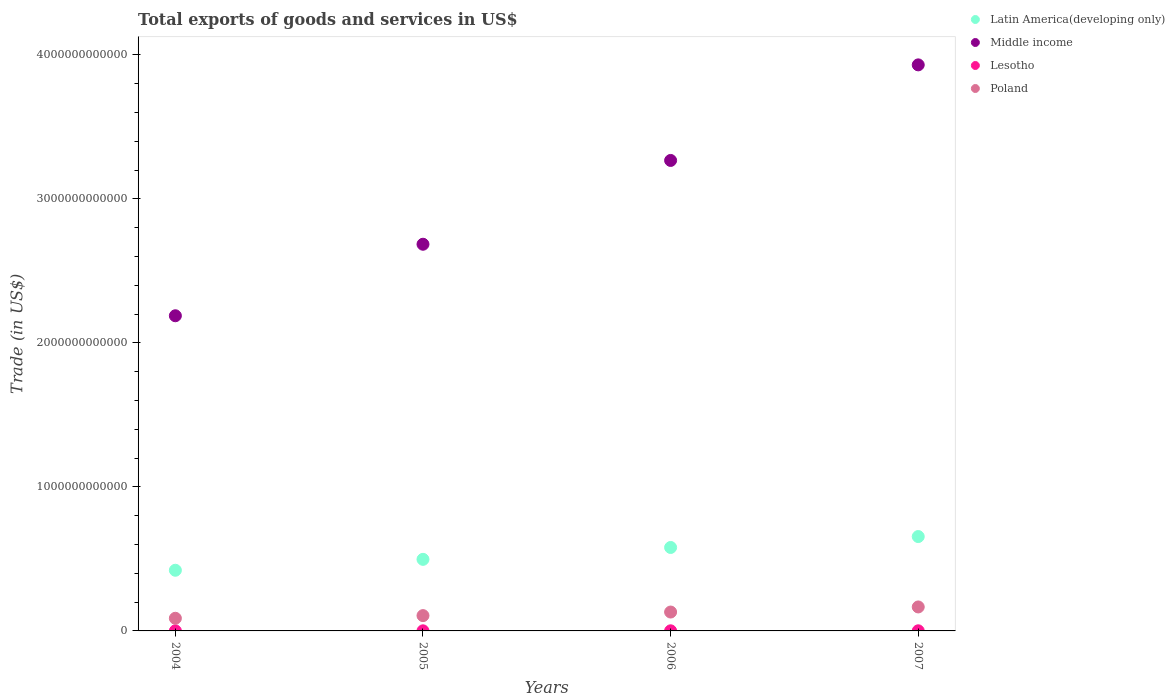How many different coloured dotlines are there?
Your answer should be very brief. 4. What is the total exports of goods and services in Poland in 2007?
Provide a succinct answer. 1.66e+11. Across all years, what is the maximum total exports of goods and services in Lesotho?
Your answer should be very brief. 8.32e+08. Across all years, what is the minimum total exports of goods and services in Lesotho?
Your answer should be compact. 6.69e+08. What is the total total exports of goods and services in Middle income in the graph?
Ensure brevity in your answer.  1.21e+13. What is the difference between the total exports of goods and services in Poland in 2005 and that in 2006?
Give a very brief answer. -2.48e+1. What is the difference between the total exports of goods and services in Middle income in 2004 and the total exports of goods and services in Lesotho in 2005?
Your response must be concise. 2.19e+12. What is the average total exports of goods and services in Lesotho per year?
Provide a succinct answer. 7.40e+08. In the year 2007, what is the difference between the total exports of goods and services in Lesotho and total exports of goods and services in Latin America(developing only)?
Give a very brief answer. -6.54e+11. What is the ratio of the total exports of goods and services in Latin America(developing only) in 2006 to that in 2007?
Keep it short and to the point. 0.88. Is the difference between the total exports of goods and services in Lesotho in 2005 and 2006 greater than the difference between the total exports of goods and services in Latin America(developing only) in 2005 and 2006?
Keep it short and to the point. Yes. What is the difference between the highest and the second highest total exports of goods and services in Poland?
Your response must be concise. 3.53e+1. What is the difference between the highest and the lowest total exports of goods and services in Poland?
Offer a terse response. 7.86e+1. In how many years, is the total exports of goods and services in Middle income greater than the average total exports of goods and services in Middle income taken over all years?
Provide a short and direct response. 2. Is the sum of the total exports of goods and services in Middle income in 2004 and 2007 greater than the maximum total exports of goods and services in Latin America(developing only) across all years?
Keep it short and to the point. Yes. Is it the case that in every year, the sum of the total exports of goods and services in Latin America(developing only) and total exports of goods and services in Middle income  is greater than the total exports of goods and services in Lesotho?
Give a very brief answer. Yes. Is the total exports of goods and services in Lesotho strictly greater than the total exports of goods and services in Poland over the years?
Offer a terse response. No. Is the total exports of goods and services in Lesotho strictly less than the total exports of goods and services in Middle income over the years?
Your response must be concise. Yes. How many years are there in the graph?
Offer a terse response. 4. What is the difference between two consecutive major ticks on the Y-axis?
Offer a terse response. 1.00e+12. Are the values on the major ticks of Y-axis written in scientific E-notation?
Provide a short and direct response. No. Does the graph contain any zero values?
Keep it short and to the point. No. What is the title of the graph?
Give a very brief answer. Total exports of goods and services in US$. What is the label or title of the Y-axis?
Your answer should be compact. Trade (in US$). What is the Trade (in US$) in Latin America(developing only) in 2004?
Give a very brief answer. 4.21e+11. What is the Trade (in US$) in Middle income in 2004?
Your answer should be very brief. 2.19e+12. What is the Trade (in US$) in Lesotho in 2004?
Your answer should be compact. 6.96e+08. What is the Trade (in US$) in Poland in 2004?
Keep it short and to the point. 8.78e+1. What is the Trade (in US$) in Latin America(developing only) in 2005?
Provide a succinct answer. 4.97e+11. What is the Trade (in US$) of Middle income in 2005?
Offer a terse response. 2.69e+12. What is the Trade (in US$) in Lesotho in 2005?
Offer a very short reply. 6.69e+08. What is the Trade (in US$) of Poland in 2005?
Offer a terse response. 1.06e+11. What is the Trade (in US$) in Latin America(developing only) in 2006?
Your response must be concise. 5.80e+11. What is the Trade (in US$) of Middle income in 2006?
Your answer should be very brief. 3.27e+12. What is the Trade (in US$) in Lesotho in 2006?
Make the answer very short. 7.65e+08. What is the Trade (in US$) of Poland in 2006?
Your answer should be compact. 1.31e+11. What is the Trade (in US$) in Latin America(developing only) in 2007?
Provide a short and direct response. 6.55e+11. What is the Trade (in US$) in Middle income in 2007?
Provide a short and direct response. 3.93e+12. What is the Trade (in US$) in Lesotho in 2007?
Your response must be concise. 8.32e+08. What is the Trade (in US$) in Poland in 2007?
Your response must be concise. 1.66e+11. Across all years, what is the maximum Trade (in US$) of Latin America(developing only)?
Your answer should be compact. 6.55e+11. Across all years, what is the maximum Trade (in US$) of Middle income?
Your answer should be very brief. 3.93e+12. Across all years, what is the maximum Trade (in US$) in Lesotho?
Provide a succinct answer. 8.32e+08. Across all years, what is the maximum Trade (in US$) in Poland?
Your response must be concise. 1.66e+11. Across all years, what is the minimum Trade (in US$) of Latin America(developing only)?
Provide a succinct answer. 4.21e+11. Across all years, what is the minimum Trade (in US$) in Middle income?
Keep it short and to the point. 2.19e+12. Across all years, what is the minimum Trade (in US$) in Lesotho?
Provide a short and direct response. 6.69e+08. Across all years, what is the minimum Trade (in US$) in Poland?
Offer a terse response. 8.78e+1. What is the total Trade (in US$) of Latin America(developing only) in the graph?
Your answer should be very brief. 2.15e+12. What is the total Trade (in US$) in Middle income in the graph?
Offer a terse response. 1.21e+13. What is the total Trade (in US$) in Lesotho in the graph?
Give a very brief answer. 2.96e+09. What is the total Trade (in US$) of Poland in the graph?
Your response must be concise. 4.92e+11. What is the difference between the Trade (in US$) of Latin America(developing only) in 2004 and that in 2005?
Offer a terse response. -7.57e+1. What is the difference between the Trade (in US$) of Middle income in 2004 and that in 2005?
Your response must be concise. -4.97e+11. What is the difference between the Trade (in US$) of Lesotho in 2004 and that in 2005?
Ensure brevity in your answer.  2.69e+07. What is the difference between the Trade (in US$) of Poland in 2004 and that in 2005?
Give a very brief answer. -1.85e+1. What is the difference between the Trade (in US$) of Latin America(developing only) in 2004 and that in 2006?
Offer a terse response. -1.58e+11. What is the difference between the Trade (in US$) of Middle income in 2004 and that in 2006?
Provide a short and direct response. -1.08e+12. What is the difference between the Trade (in US$) of Lesotho in 2004 and that in 2006?
Your response must be concise. -6.94e+07. What is the difference between the Trade (in US$) in Poland in 2004 and that in 2006?
Your response must be concise. -4.33e+1. What is the difference between the Trade (in US$) of Latin America(developing only) in 2004 and that in 2007?
Offer a very short reply. -2.34e+11. What is the difference between the Trade (in US$) of Middle income in 2004 and that in 2007?
Offer a terse response. -1.74e+12. What is the difference between the Trade (in US$) in Lesotho in 2004 and that in 2007?
Provide a short and direct response. -1.37e+08. What is the difference between the Trade (in US$) in Poland in 2004 and that in 2007?
Your response must be concise. -7.86e+1. What is the difference between the Trade (in US$) in Latin America(developing only) in 2005 and that in 2006?
Your answer should be very brief. -8.25e+1. What is the difference between the Trade (in US$) in Middle income in 2005 and that in 2006?
Your answer should be compact. -5.82e+11. What is the difference between the Trade (in US$) of Lesotho in 2005 and that in 2006?
Offer a very short reply. -9.64e+07. What is the difference between the Trade (in US$) of Poland in 2005 and that in 2006?
Provide a short and direct response. -2.48e+1. What is the difference between the Trade (in US$) of Latin America(developing only) in 2005 and that in 2007?
Provide a short and direct response. -1.58e+11. What is the difference between the Trade (in US$) in Middle income in 2005 and that in 2007?
Your response must be concise. -1.25e+12. What is the difference between the Trade (in US$) of Lesotho in 2005 and that in 2007?
Ensure brevity in your answer.  -1.63e+08. What is the difference between the Trade (in US$) of Poland in 2005 and that in 2007?
Provide a succinct answer. -6.02e+1. What is the difference between the Trade (in US$) in Latin America(developing only) in 2006 and that in 2007?
Keep it short and to the point. -7.58e+1. What is the difference between the Trade (in US$) in Middle income in 2006 and that in 2007?
Your answer should be compact. -6.64e+11. What is the difference between the Trade (in US$) in Lesotho in 2006 and that in 2007?
Make the answer very short. -6.71e+07. What is the difference between the Trade (in US$) of Poland in 2006 and that in 2007?
Give a very brief answer. -3.53e+1. What is the difference between the Trade (in US$) of Latin America(developing only) in 2004 and the Trade (in US$) of Middle income in 2005?
Your answer should be compact. -2.26e+12. What is the difference between the Trade (in US$) of Latin America(developing only) in 2004 and the Trade (in US$) of Lesotho in 2005?
Ensure brevity in your answer.  4.21e+11. What is the difference between the Trade (in US$) in Latin America(developing only) in 2004 and the Trade (in US$) in Poland in 2005?
Your answer should be compact. 3.15e+11. What is the difference between the Trade (in US$) in Middle income in 2004 and the Trade (in US$) in Lesotho in 2005?
Ensure brevity in your answer.  2.19e+12. What is the difference between the Trade (in US$) in Middle income in 2004 and the Trade (in US$) in Poland in 2005?
Your answer should be compact. 2.08e+12. What is the difference between the Trade (in US$) in Lesotho in 2004 and the Trade (in US$) in Poland in 2005?
Your answer should be very brief. -1.06e+11. What is the difference between the Trade (in US$) in Latin America(developing only) in 2004 and the Trade (in US$) in Middle income in 2006?
Your response must be concise. -2.85e+12. What is the difference between the Trade (in US$) of Latin America(developing only) in 2004 and the Trade (in US$) of Lesotho in 2006?
Your answer should be very brief. 4.21e+11. What is the difference between the Trade (in US$) in Latin America(developing only) in 2004 and the Trade (in US$) in Poland in 2006?
Your answer should be compact. 2.90e+11. What is the difference between the Trade (in US$) of Middle income in 2004 and the Trade (in US$) of Lesotho in 2006?
Provide a succinct answer. 2.19e+12. What is the difference between the Trade (in US$) in Middle income in 2004 and the Trade (in US$) in Poland in 2006?
Your answer should be compact. 2.06e+12. What is the difference between the Trade (in US$) in Lesotho in 2004 and the Trade (in US$) in Poland in 2006?
Provide a succinct answer. -1.30e+11. What is the difference between the Trade (in US$) of Latin America(developing only) in 2004 and the Trade (in US$) of Middle income in 2007?
Keep it short and to the point. -3.51e+12. What is the difference between the Trade (in US$) in Latin America(developing only) in 2004 and the Trade (in US$) in Lesotho in 2007?
Your response must be concise. 4.20e+11. What is the difference between the Trade (in US$) of Latin America(developing only) in 2004 and the Trade (in US$) of Poland in 2007?
Your answer should be very brief. 2.55e+11. What is the difference between the Trade (in US$) of Middle income in 2004 and the Trade (in US$) of Lesotho in 2007?
Give a very brief answer. 2.19e+12. What is the difference between the Trade (in US$) of Middle income in 2004 and the Trade (in US$) of Poland in 2007?
Offer a very short reply. 2.02e+12. What is the difference between the Trade (in US$) in Lesotho in 2004 and the Trade (in US$) in Poland in 2007?
Offer a very short reply. -1.66e+11. What is the difference between the Trade (in US$) of Latin America(developing only) in 2005 and the Trade (in US$) of Middle income in 2006?
Provide a short and direct response. -2.77e+12. What is the difference between the Trade (in US$) in Latin America(developing only) in 2005 and the Trade (in US$) in Lesotho in 2006?
Your answer should be very brief. 4.96e+11. What is the difference between the Trade (in US$) in Latin America(developing only) in 2005 and the Trade (in US$) in Poland in 2006?
Keep it short and to the point. 3.66e+11. What is the difference between the Trade (in US$) in Middle income in 2005 and the Trade (in US$) in Lesotho in 2006?
Give a very brief answer. 2.68e+12. What is the difference between the Trade (in US$) in Middle income in 2005 and the Trade (in US$) in Poland in 2006?
Keep it short and to the point. 2.55e+12. What is the difference between the Trade (in US$) of Lesotho in 2005 and the Trade (in US$) of Poland in 2006?
Provide a succinct answer. -1.30e+11. What is the difference between the Trade (in US$) in Latin America(developing only) in 2005 and the Trade (in US$) in Middle income in 2007?
Your answer should be very brief. -3.43e+12. What is the difference between the Trade (in US$) of Latin America(developing only) in 2005 and the Trade (in US$) of Lesotho in 2007?
Your response must be concise. 4.96e+11. What is the difference between the Trade (in US$) of Latin America(developing only) in 2005 and the Trade (in US$) of Poland in 2007?
Provide a short and direct response. 3.31e+11. What is the difference between the Trade (in US$) of Middle income in 2005 and the Trade (in US$) of Lesotho in 2007?
Ensure brevity in your answer.  2.68e+12. What is the difference between the Trade (in US$) in Middle income in 2005 and the Trade (in US$) in Poland in 2007?
Ensure brevity in your answer.  2.52e+12. What is the difference between the Trade (in US$) in Lesotho in 2005 and the Trade (in US$) in Poland in 2007?
Make the answer very short. -1.66e+11. What is the difference between the Trade (in US$) of Latin America(developing only) in 2006 and the Trade (in US$) of Middle income in 2007?
Your answer should be compact. -3.35e+12. What is the difference between the Trade (in US$) of Latin America(developing only) in 2006 and the Trade (in US$) of Lesotho in 2007?
Provide a short and direct response. 5.79e+11. What is the difference between the Trade (in US$) in Latin America(developing only) in 2006 and the Trade (in US$) in Poland in 2007?
Ensure brevity in your answer.  4.13e+11. What is the difference between the Trade (in US$) of Middle income in 2006 and the Trade (in US$) of Lesotho in 2007?
Offer a terse response. 3.27e+12. What is the difference between the Trade (in US$) of Middle income in 2006 and the Trade (in US$) of Poland in 2007?
Make the answer very short. 3.10e+12. What is the difference between the Trade (in US$) in Lesotho in 2006 and the Trade (in US$) in Poland in 2007?
Keep it short and to the point. -1.66e+11. What is the average Trade (in US$) in Latin America(developing only) per year?
Your answer should be compact. 5.38e+11. What is the average Trade (in US$) of Middle income per year?
Your answer should be compact. 3.02e+12. What is the average Trade (in US$) of Lesotho per year?
Make the answer very short. 7.40e+08. What is the average Trade (in US$) in Poland per year?
Your response must be concise. 1.23e+11. In the year 2004, what is the difference between the Trade (in US$) in Latin America(developing only) and Trade (in US$) in Middle income?
Your answer should be compact. -1.77e+12. In the year 2004, what is the difference between the Trade (in US$) of Latin America(developing only) and Trade (in US$) of Lesotho?
Your response must be concise. 4.21e+11. In the year 2004, what is the difference between the Trade (in US$) of Latin America(developing only) and Trade (in US$) of Poland?
Your response must be concise. 3.33e+11. In the year 2004, what is the difference between the Trade (in US$) in Middle income and Trade (in US$) in Lesotho?
Give a very brief answer. 2.19e+12. In the year 2004, what is the difference between the Trade (in US$) in Middle income and Trade (in US$) in Poland?
Your answer should be very brief. 2.10e+12. In the year 2004, what is the difference between the Trade (in US$) in Lesotho and Trade (in US$) in Poland?
Offer a very short reply. -8.71e+1. In the year 2005, what is the difference between the Trade (in US$) in Latin America(developing only) and Trade (in US$) in Middle income?
Make the answer very short. -2.19e+12. In the year 2005, what is the difference between the Trade (in US$) in Latin America(developing only) and Trade (in US$) in Lesotho?
Your response must be concise. 4.96e+11. In the year 2005, what is the difference between the Trade (in US$) in Latin America(developing only) and Trade (in US$) in Poland?
Provide a succinct answer. 3.91e+11. In the year 2005, what is the difference between the Trade (in US$) in Middle income and Trade (in US$) in Lesotho?
Keep it short and to the point. 2.68e+12. In the year 2005, what is the difference between the Trade (in US$) in Middle income and Trade (in US$) in Poland?
Give a very brief answer. 2.58e+12. In the year 2005, what is the difference between the Trade (in US$) of Lesotho and Trade (in US$) of Poland?
Ensure brevity in your answer.  -1.06e+11. In the year 2006, what is the difference between the Trade (in US$) of Latin America(developing only) and Trade (in US$) of Middle income?
Offer a very short reply. -2.69e+12. In the year 2006, what is the difference between the Trade (in US$) in Latin America(developing only) and Trade (in US$) in Lesotho?
Offer a terse response. 5.79e+11. In the year 2006, what is the difference between the Trade (in US$) of Latin America(developing only) and Trade (in US$) of Poland?
Offer a very short reply. 4.48e+11. In the year 2006, what is the difference between the Trade (in US$) of Middle income and Trade (in US$) of Lesotho?
Ensure brevity in your answer.  3.27e+12. In the year 2006, what is the difference between the Trade (in US$) in Middle income and Trade (in US$) in Poland?
Your response must be concise. 3.14e+12. In the year 2006, what is the difference between the Trade (in US$) of Lesotho and Trade (in US$) of Poland?
Provide a short and direct response. -1.30e+11. In the year 2007, what is the difference between the Trade (in US$) in Latin America(developing only) and Trade (in US$) in Middle income?
Give a very brief answer. -3.28e+12. In the year 2007, what is the difference between the Trade (in US$) of Latin America(developing only) and Trade (in US$) of Lesotho?
Provide a succinct answer. 6.54e+11. In the year 2007, what is the difference between the Trade (in US$) in Latin America(developing only) and Trade (in US$) in Poland?
Give a very brief answer. 4.89e+11. In the year 2007, what is the difference between the Trade (in US$) of Middle income and Trade (in US$) of Lesotho?
Your response must be concise. 3.93e+12. In the year 2007, what is the difference between the Trade (in US$) in Middle income and Trade (in US$) in Poland?
Provide a succinct answer. 3.76e+12. In the year 2007, what is the difference between the Trade (in US$) of Lesotho and Trade (in US$) of Poland?
Offer a terse response. -1.66e+11. What is the ratio of the Trade (in US$) of Latin America(developing only) in 2004 to that in 2005?
Give a very brief answer. 0.85. What is the ratio of the Trade (in US$) in Middle income in 2004 to that in 2005?
Provide a short and direct response. 0.81. What is the ratio of the Trade (in US$) in Lesotho in 2004 to that in 2005?
Make the answer very short. 1.04. What is the ratio of the Trade (in US$) of Poland in 2004 to that in 2005?
Make the answer very short. 0.83. What is the ratio of the Trade (in US$) of Latin America(developing only) in 2004 to that in 2006?
Your answer should be compact. 0.73. What is the ratio of the Trade (in US$) in Middle income in 2004 to that in 2006?
Provide a short and direct response. 0.67. What is the ratio of the Trade (in US$) of Lesotho in 2004 to that in 2006?
Your answer should be very brief. 0.91. What is the ratio of the Trade (in US$) in Poland in 2004 to that in 2006?
Your answer should be very brief. 0.67. What is the ratio of the Trade (in US$) of Latin America(developing only) in 2004 to that in 2007?
Provide a succinct answer. 0.64. What is the ratio of the Trade (in US$) in Middle income in 2004 to that in 2007?
Give a very brief answer. 0.56. What is the ratio of the Trade (in US$) in Lesotho in 2004 to that in 2007?
Keep it short and to the point. 0.84. What is the ratio of the Trade (in US$) of Poland in 2004 to that in 2007?
Offer a terse response. 0.53. What is the ratio of the Trade (in US$) in Latin America(developing only) in 2005 to that in 2006?
Give a very brief answer. 0.86. What is the ratio of the Trade (in US$) of Middle income in 2005 to that in 2006?
Offer a terse response. 0.82. What is the ratio of the Trade (in US$) of Lesotho in 2005 to that in 2006?
Provide a succinct answer. 0.87. What is the ratio of the Trade (in US$) in Poland in 2005 to that in 2006?
Your response must be concise. 0.81. What is the ratio of the Trade (in US$) in Latin America(developing only) in 2005 to that in 2007?
Ensure brevity in your answer.  0.76. What is the ratio of the Trade (in US$) in Middle income in 2005 to that in 2007?
Offer a very short reply. 0.68. What is the ratio of the Trade (in US$) of Lesotho in 2005 to that in 2007?
Offer a very short reply. 0.8. What is the ratio of the Trade (in US$) of Poland in 2005 to that in 2007?
Give a very brief answer. 0.64. What is the ratio of the Trade (in US$) of Latin America(developing only) in 2006 to that in 2007?
Provide a short and direct response. 0.88. What is the ratio of the Trade (in US$) of Middle income in 2006 to that in 2007?
Your answer should be compact. 0.83. What is the ratio of the Trade (in US$) of Lesotho in 2006 to that in 2007?
Offer a terse response. 0.92. What is the ratio of the Trade (in US$) of Poland in 2006 to that in 2007?
Give a very brief answer. 0.79. What is the difference between the highest and the second highest Trade (in US$) in Latin America(developing only)?
Your answer should be very brief. 7.58e+1. What is the difference between the highest and the second highest Trade (in US$) in Middle income?
Your response must be concise. 6.64e+11. What is the difference between the highest and the second highest Trade (in US$) in Lesotho?
Keep it short and to the point. 6.71e+07. What is the difference between the highest and the second highest Trade (in US$) of Poland?
Provide a short and direct response. 3.53e+1. What is the difference between the highest and the lowest Trade (in US$) in Latin America(developing only)?
Your answer should be very brief. 2.34e+11. What is the difference between the highest and the lowest Trade (in US$) of Middle income?
Your answer should be compact. 1.74e+12. What is the difference between the highest and the lowest Trade (in US$) of Lesotho?
Offer a very short reply. 1.63e+08. What is the difference between the highest and the lowest Trade (in US$) of Poland?
Your answer should be very brief. 7.86e+1. 